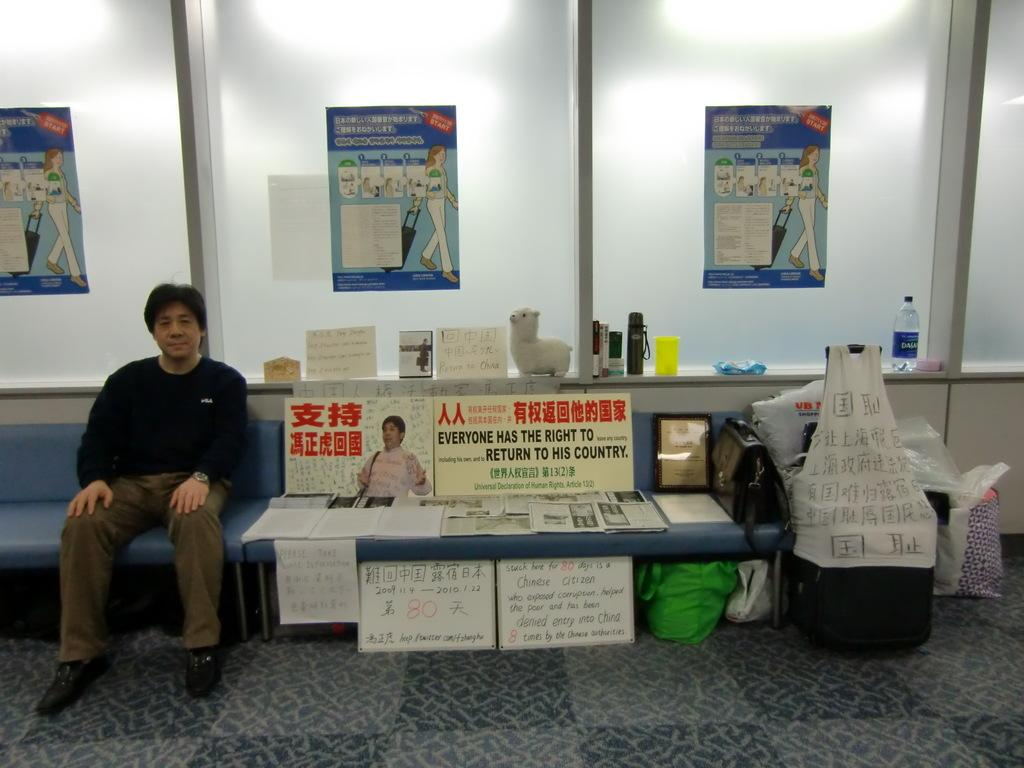What is the man in the image doing? The man is sitting on a chair in the image. What can be seen on the walls in the image? There are posters in the image. What type of items are present on the surface in the image? There are papers, a bag, a frame, a toy, a water bottle, and a cup in the image. What invention is the man crediting in the image? There is no invention or credit mentioned in the image; it simply shows a man sitting on a chair with various items around him. Who is the coach in the image? There is no coach present in the image. 